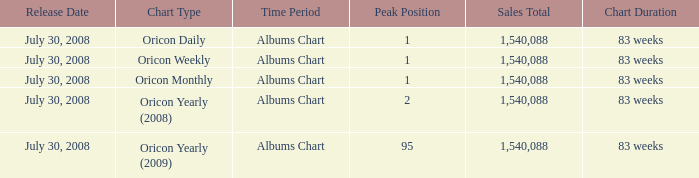How much Peak Position has Sales Total larger than 1,540,088? 0.0. Help me parse the entirety of this table. {'header': ['Release Date', 'Chart Type', 'Time Period', 'Peak Position', 'Sales Total', 'Chart Duration'], 'rows': [['July 30, 2008', 'Oricon Daily', 'Albums Chart', '1', '1,540,088', '83 weeks'], ['July 30, 2008', 'Oricon Weekly', 'Albums Chart', '1', '1,540,088', '83 weeks'], ['July 30, 2008', 'Oricon Monthly', 'Albums Chart', '1', '1,540,088', '83 weeks'], ['July 30, 2008', 'Oricon Yearly (2008)', 'Albums Chart', '2', '1,540,088', '83 weeks'], ['July 30, 2008', 'Oricon Yearly (2009)', 'Albums Chart', '95', '1,540,088', '83 weeks']]} 